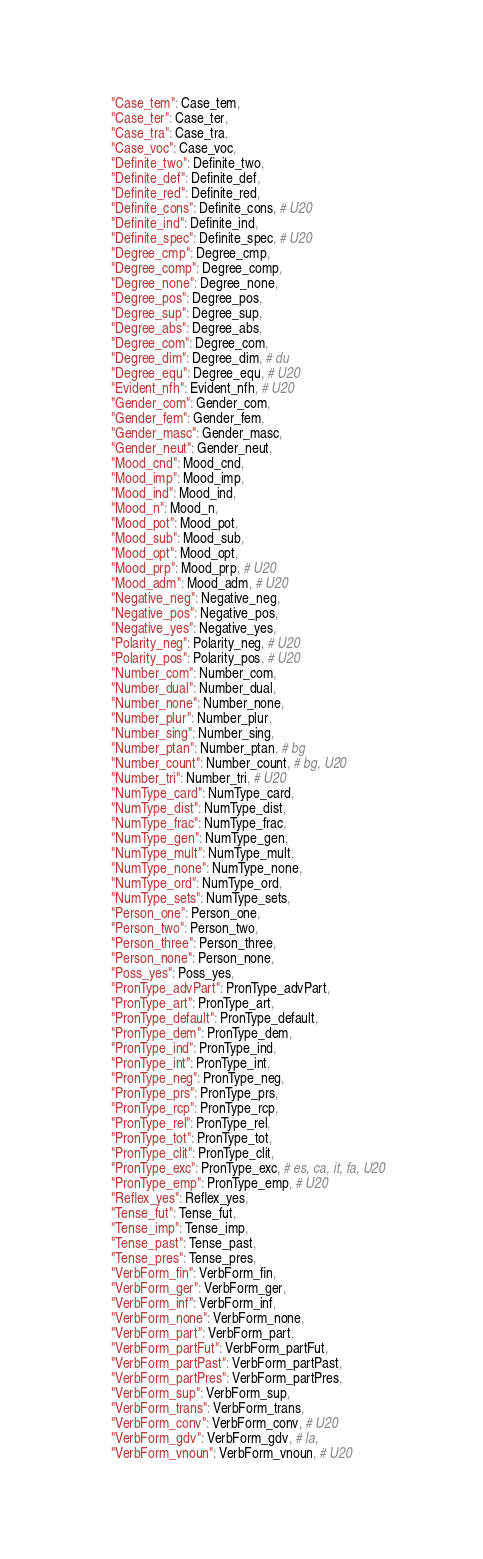<code> <loc_0><loc_0><loc_500><loc_500><_Cython_>    "Case_tem": Case_tem,
    "Case_ter": Case_ter,
    "Case_tra": Case_tra,
    "Case_voc": Case_voc,
    "Definite_two": Definite_two,
    "Definite_def": Definite_def,
    "Definite_red": Definite_red,
    "Definite_cons": Definite_cons, # U20
    "Definite_ind": Definite_ind,
    "Definite_spec": Definite_spec, # U20
    "Degree_cmp": Degree_cmp,
    "Degree_comp": Degree_comp,
    "Degree_none": Degree_none,
    "Degree_pos": Degree_pos,
    "Degree_sup": Degree_sup,
    "Degree_abs": Degree_abs,
    "Degree_com": Degree_com,
    "Degree_dim": Degree_dim, # du
    "Degree_equ": Degree_equ, # U20
    "Evident_nfh": Evident_nfh, # U20
    "Gender_com": Gender_com,
    "Gender_fem": Gender_fem,
    "Gender_masc": Gender_masc,
    "Gender_neut": Gender_neut,
    "Mood_cnd": Mood_cnd,
    "Mood_imp": Mood_imp,
    "Mood_ind": Mood_ind,
    "Mood_n": Mood_n,
    "Mood_pot": Mood_pot,
    "Mood_sub": Mood_sub,
    "Mood_opt": Mood_opt,
    "Mood_prp": Mood_prp, # U20
    "Mood_adm": Mood_adm, # U20
    "Negative_neg": Negative_neg,
    "Negative_pos": Negative_pos,
    "Negative_yes": Negative_yes,
    "Polarity_neg": Polarity_neg, # U20
    "Polarity_pos": Polarity_pos, # U20
    "Number_com": Number_com,
    "Number_dual": Number_dual,
    "Number_none": Number_none,
    "Number_plur": Number_plur,
    "Number_sing": Number_sing,
    "Number_ptan": Number_ptan, # bg
    "Number_count": Number_count, # bg, U20
    "Number_tri": Number_tri, # U20
    "NumType_card": NumType_card,
    "NumType_dist": NumType_dist,
    "NumType_frac": NumType_frac,
    "NumType_gen": NumType_gen,
    "NumType_mult": NumType_mult,
    "NumType_none": NumType_none,
    "NumType_ord": NumType_ord,
    "NumType_sets": NumType_sets,
    "Person_one": Person_one,
    "Person_two": Person_two,
    "Person_three": Person_three,
    "Person_none": Person_none,
    "Poss_yes": Poss_yes,
    "PronType_advPart": PronType_advPart,
    "PronType_art": PronType_art,
    "PronType_default": PronType_default,
    "PronType_dem": PronType_dem,
    "PronType_ind": PronType_ind,
    "PronType_int": PronType_int,
    "PronType_neg": PronType_neg,
    "PronType_prs": PronType_prs,
    "PronType_rcp": PronType_rcp,
    "PronType_rel": PronType_rel,
    "PronType_tot": PronType_tot,
    "PronType_clit": PronType_clit,
    "PronType_exc": PronType_exc, # es, ca, it, fa, U20
    "PronType_emp": PronType_emp, # U20
    "Reflex_yes": Reflex_yes,
    "Tense_fut": Tense_fut,
    "Tense_imp": Tense_imp,
    "Tense_past": Tense_past,
    "Tense_pres": Tense_pres,
    "VerbForm_fin": VerbForm_fin,
    "VerbForm_ger": VerbForm_ger,
    "VerbForm_inf": VerbForm_inf,
    "VerbForm_none": VerbForm_none,
    "VerbForm_part": VerbForm_part,
    "VerbForm_partFut": VerbForm_partFut,
    "VerbForm_partPast": VerbForm_partPast,
    "VerbForm_partPres": VerbForm_partPres,
    "VerbForm_sup": VerbForm_sup,
    "VerbForm_trans": VerbForm_trans,
    "VerbForm_conv": VerbForm_conv, # U20
    "VerbForm_gdv": VerbForm_gdv, # la,
    "VerbForm_vnoun": VerbForm_vnoun, # U20</code> 